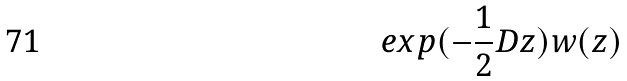<formula> <loc_0><loc_0><loc_500><loc_500>e x p ( - \frac { 1 } { 2 } D z ) w ( z )</formula> 